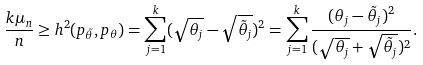<formula> <loc_0><loc_0><loc_500><loc_500>\frac { k \mu _ { n } } { n } & \geq h ^ { 2 } ( p _ { \tilde { \theta } } , p _ { \theta } ) = \sum _ { j = 1 } ^ { k } ( \sqrt { \theta _ { j } } - \sqrt { \tilde { \theta } _ { j } } ) ^ { 2 } = \sum _ { j = 1 } ^ { k } \frac { ( \theta _ { j } - \tilde { \theta } _ { j } ) ^ { 2 } } { ( \sqrt { \theta _ { j } } + \sqrt { \tilde { \theta } _ { j } } ) ^ { 2 } } .</formula> 